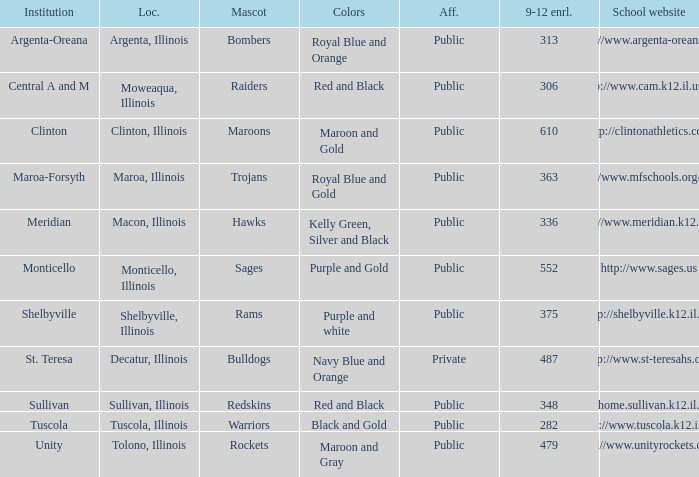What are the team colors from Tolono, Illinois? Maroon and Gray. 